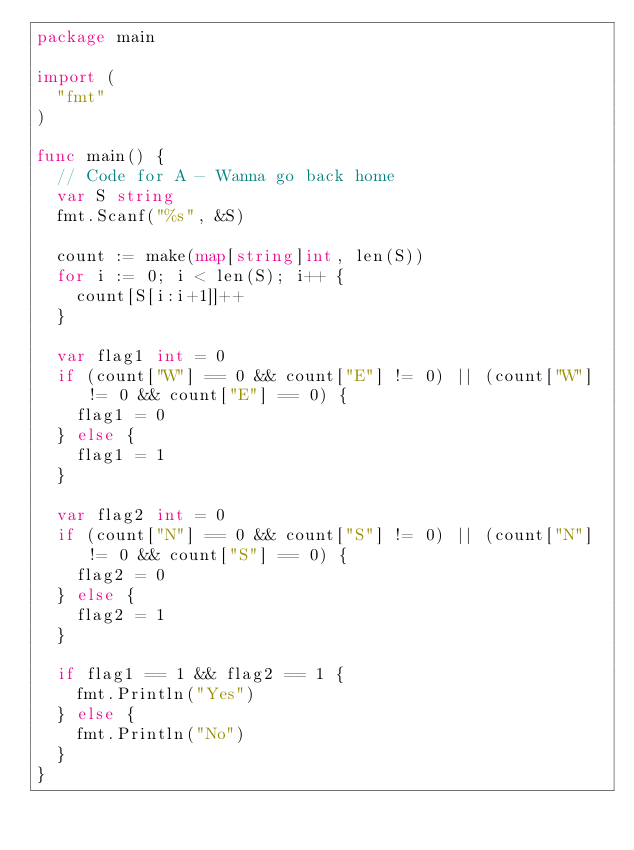<code> <loc_0><loc_0><loc_500><loc_500><_Go_>package main

import (
	"fmt"
)

func main() {
	// Code for A - Wanna go back home
	var S string
	fmt.Scanf("%s", &S)

	count := make(map[string]int, len(S))
	for i := 0; i < len(S); i++ {
		count[S[i:i+1]]++
	}

	var flag1 int = 0
	if (count["W"] == 0 && count["E"] != 0) || (count["W"] != 0 && count["E"] == 0) {
		flag1 = 0
	} else {
		flag1 = 1
	}

	var flag2 int = 0
	if (count["N"] == 0 && count["S"] != 0) || (count["N"] != 0 && count["S"] == 0) {
		flag2 = 0
	} else {
		flag2 = 1
	}

	if flag1 == 1 && flag2 == 1 {
		fmt.Println("Yes")
	} else {
		fmt.Println("No")
	}
}
</code> 